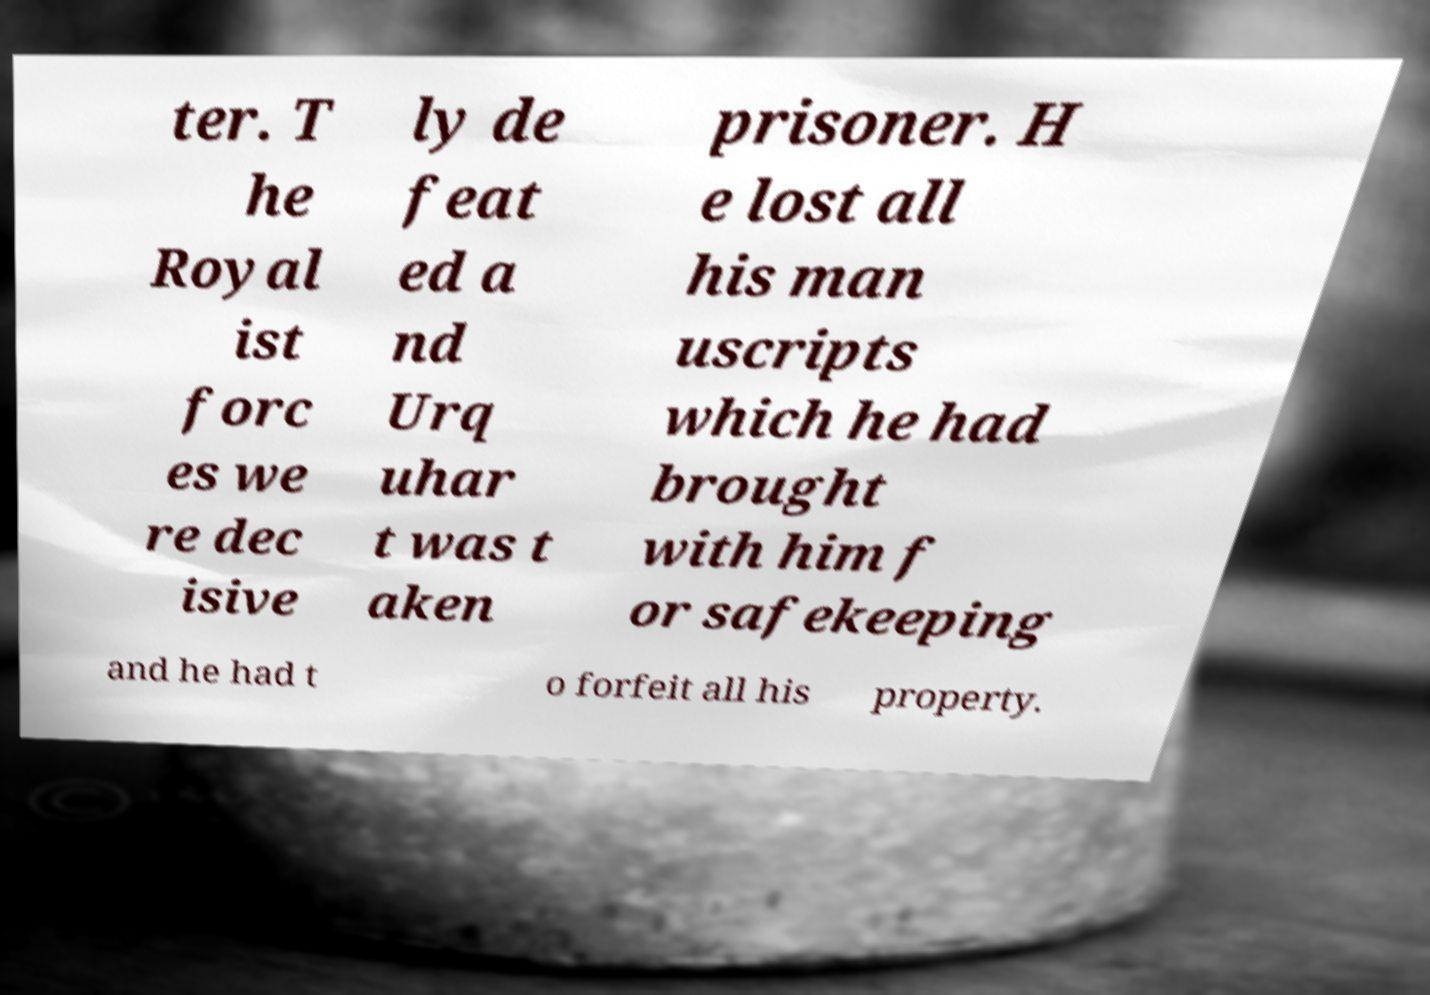For documentation purposes, I need the text within this image transcribed. Could you provide that? ter. T he Royal ist forc es we re dec isive ly de feat ed a nd Urq uhar t was t aken prisoner. H e lost all his man uscripts which he had brought with him f or safekeeping and he had t o forfeit all his property. 